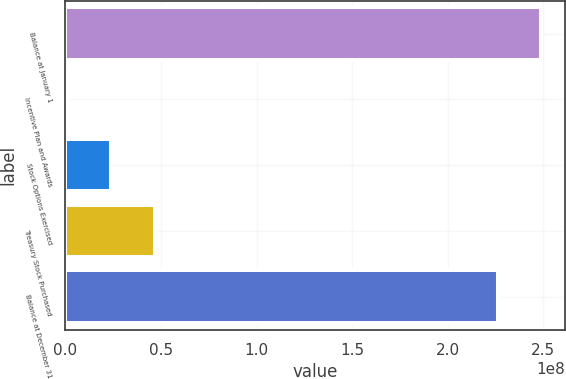Convert chart to OTSL. <chart><loc_0><loc_0><loc_500><loc_500><bar_chart><fcel>Balance at January 1<fcel>Incentive Plan and Awards<fcel>Stock Options Exercised<fcel>Treasury Stock Purchased<fcel>Balance at December 31<nl><fcel>2.48855e+08<fcel>1.32013e+06<fcel>2.40487e+07<fcel>4.67772e+07<fcel>2.26127e+08<nl></chart> 